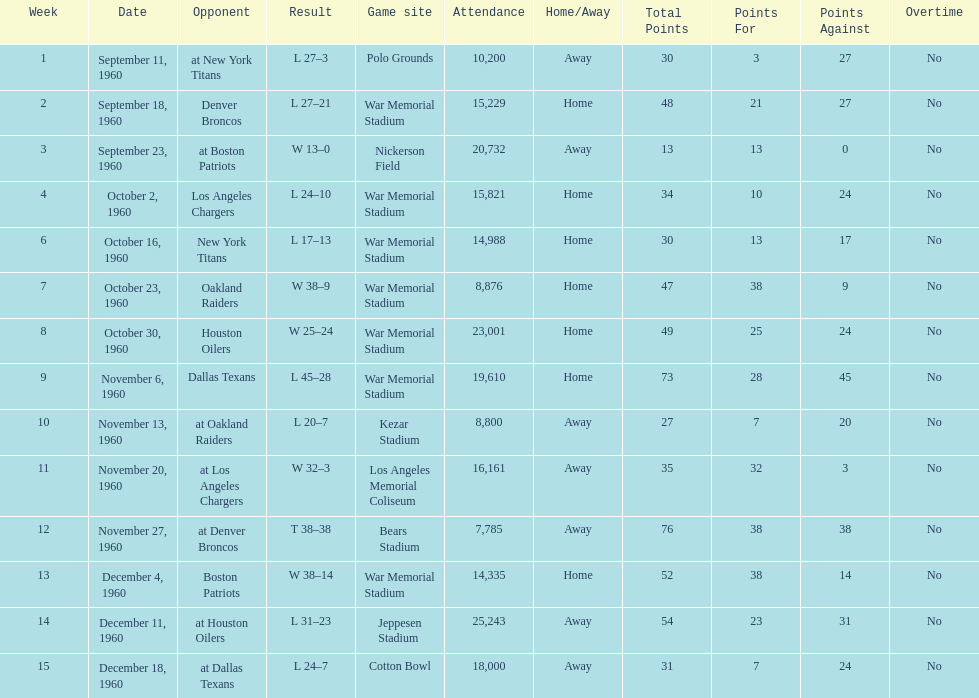How many games had at least 10,000 people in attendance? 11. 